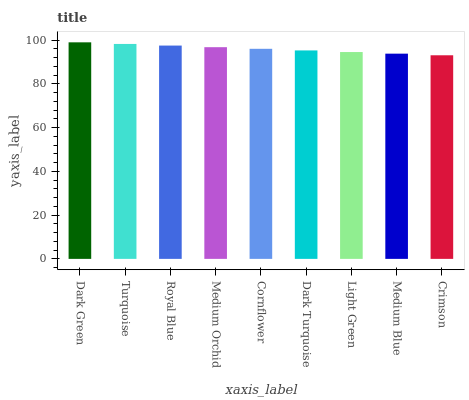Is Turquoise the minimum?
Answer yes or no. No. Is Turquoise the maximum?
Answer yes or no. No. Is Dark Green greater than Turquoise?
Answer yes or no. Yes. Is Turquoise less than Dark Green?
Answer yes or no. Yes. Is Turquoise greater than Dark Green?
Answer yes or no. No. Is Dark Green less than Turquoise?
Answer yes or no. No. Is Cornflower the high median?
Answer yes or no. Yes. Is Cornflower the low median?
Answer yes or no. Yes. Is Crimson the high median?
Answer yes or no. No. Is Medium Blue the low median?
Answer yes or no. No. 